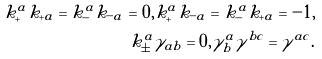Convert formula to latex. <formula><loc_0><loc_0><loc_500><loc_500>k _ { + } ^ { a } k _ { + a } = k _ { - } ^ { a } k _ { - a } = 0 , k _ { + } ^ { a } k _ { - a } = k _ { - } ^ { a } k _ { + a } = - 1 , \\ k _ { \pm } ^ { a } \gamma _ { a b } = 0 , \gamma ^ { a } _ { b } \gamma ^ { b c } = \gamma ^ { a c } .</formula> 